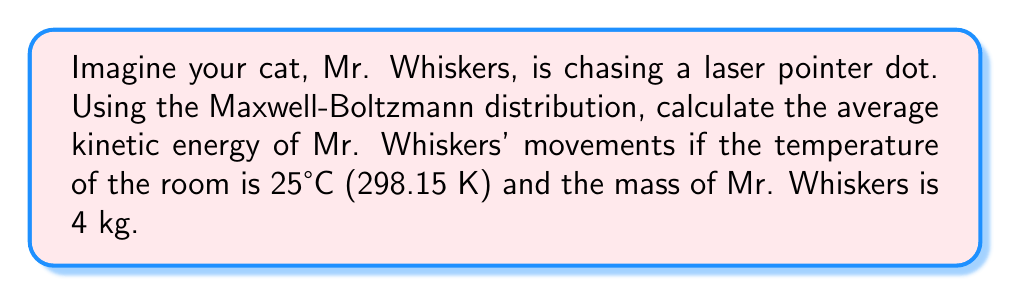Solve this math problem. To solve this problem, we'll use the Maxwell-Boltzmann distribution to calculate the average kinetic energy of Mr. Whiskers' movements. Here's the step-by-step solution:

1) The average kinetic energy in the Maxwell-Boltzmann distribution is given by:

   $$\langle E_k \rangle = \frac{3}{2}k_BT$$

   Where $k_B$ is the Boltzmann constant and $T$ is the temperature in Kelvin.

2) We're given:
   - Temperature, $T = 298.15$ K
   - Boltzmann constant, $k_B = 1.380649 \times 10^{-23}$ J/K

3) Let's substitute these values into our equation:

   $$\langle E_k \rangle = \frac{3}{2} \times (1.380649 \times 10^{-23} \text{ J/K}) \times (298.15 \text{ K})$$

4) Now, let's calculate:

   $$\langle E_k \rangle = 6.17 \times 10^{-21} \text{ J}$$

5) To make this more relatable to Mr. Whiskers' movements, we can convert this to electron volts (eV):

   $$6.17 \times 10^{-21} \text{ J} \times \frac{1 \text{ eV}}{1.602176634 \times 10^{-19} \text{ J}} = 0.0385 \text{ eV}$$

Note: The mass of Mr. Whiskers (4 kg) wasn't needed for this calculation, as the average kinetic energy in the Maxwell-Boltzmann distribution depends only on temperature, not mass.
Answer: $0.0385 \text{ eV}$ 